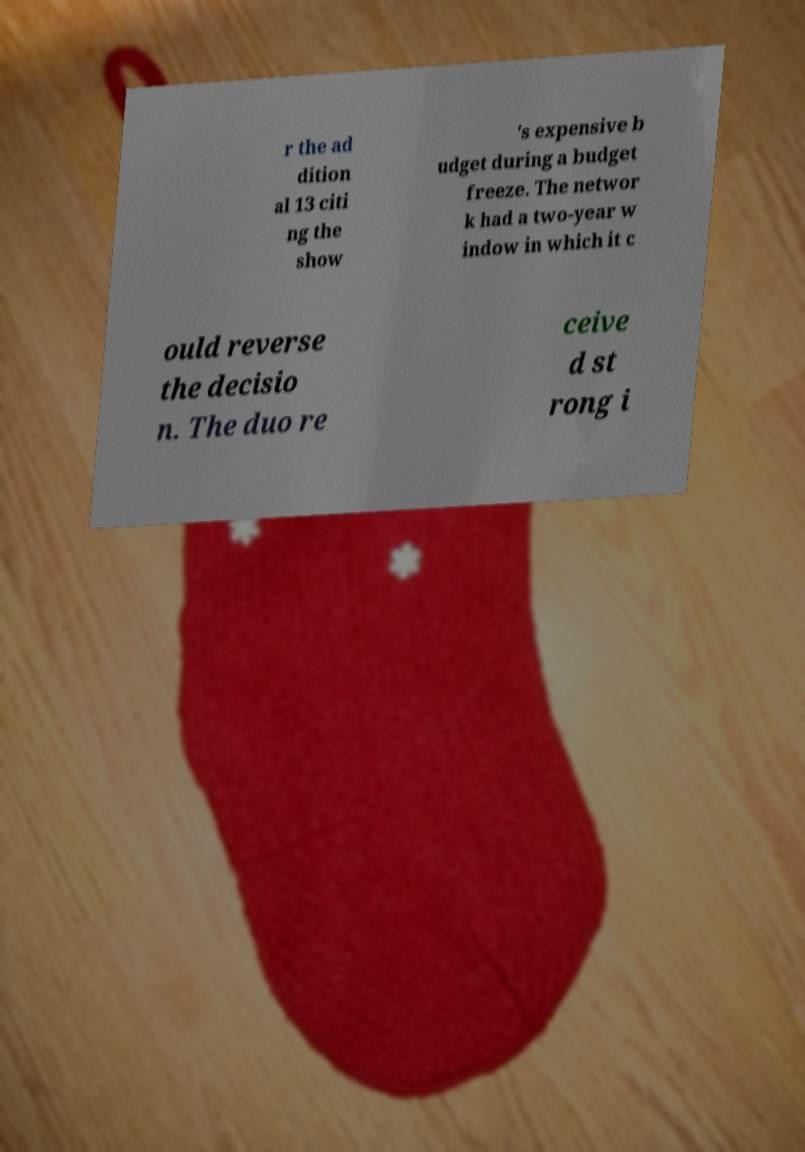Can you read and provide the text displayed in the image?This photo seems to have some interesting text. Can you extract and type it out for me? r the ad dition al 13 citi ng the show 's expensive b udget during a budget freeze. The networ k had a two-year w indow in which it c ould reverse the decisio n. The duo re ceive d st rong i 